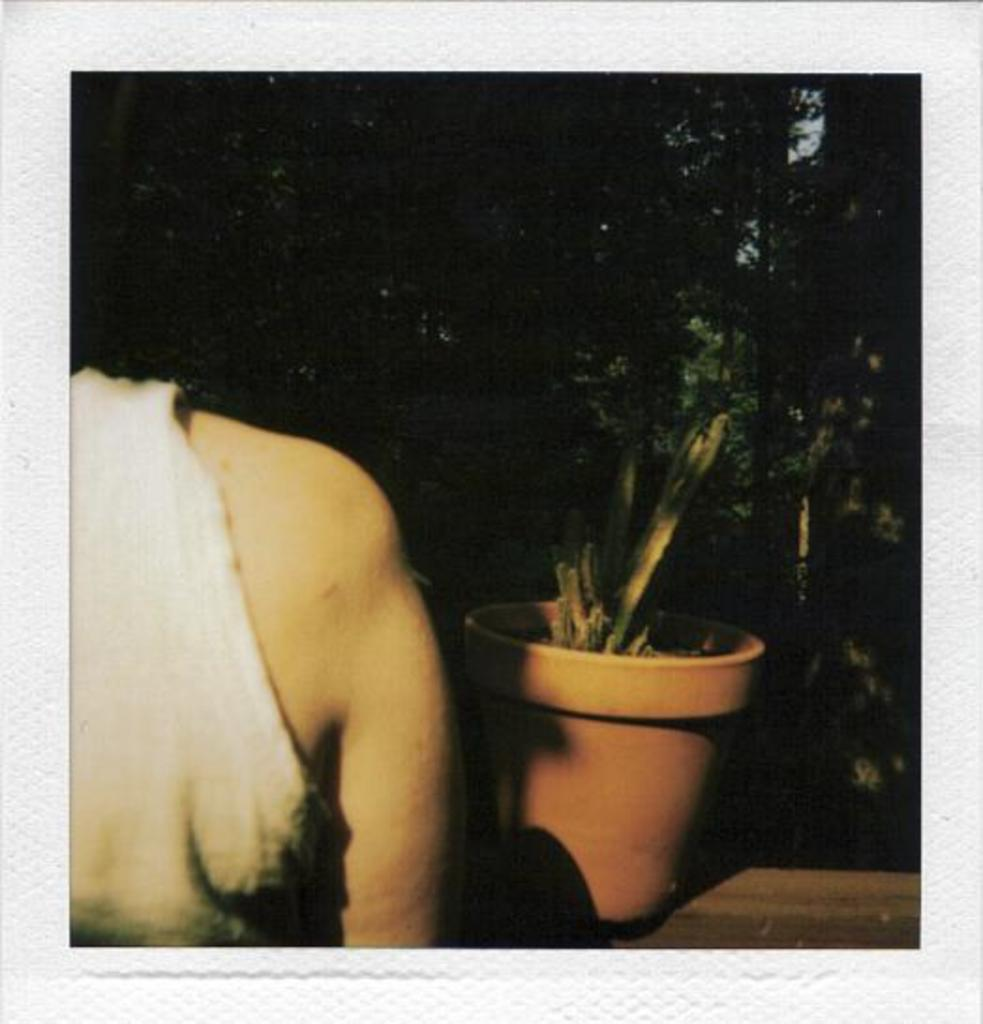What is present in the image? There is a person and a plant on the wall in the image. Can you describe the plant on the wall? The plant on the wall is a vertical garden or a climbing plant. What else can be seen in the image? There is a tree visible in the image. What type of yak can be seen in the image? There is no yak present in the image. What is the mother of the person in the image doing? The provided facts do not mention a mother or any activity related to a mother, so we cannot answer this question. 